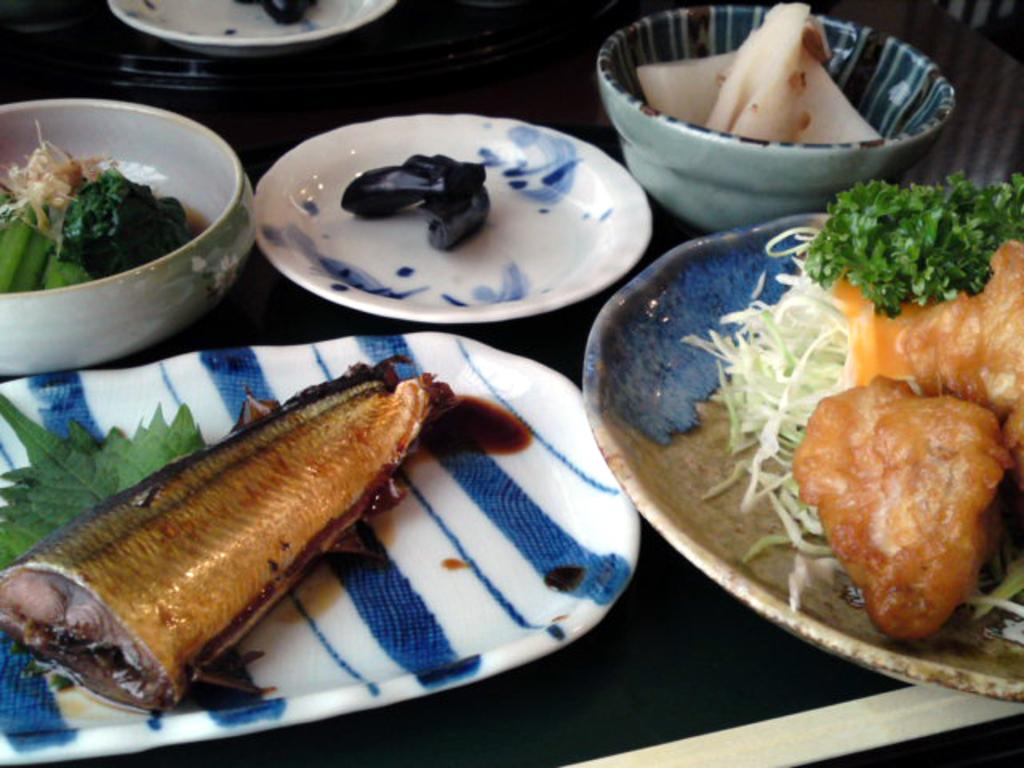What piece of furniture is present in the image? There is a table in the image. What is placed on the table? There are plates on the table. What can be found inside the plates? There is a food item in the plates. Can you see an ant carrying a piece of the food item in the image? There is no ant present in the image, and therefore no such activity can be observed. 